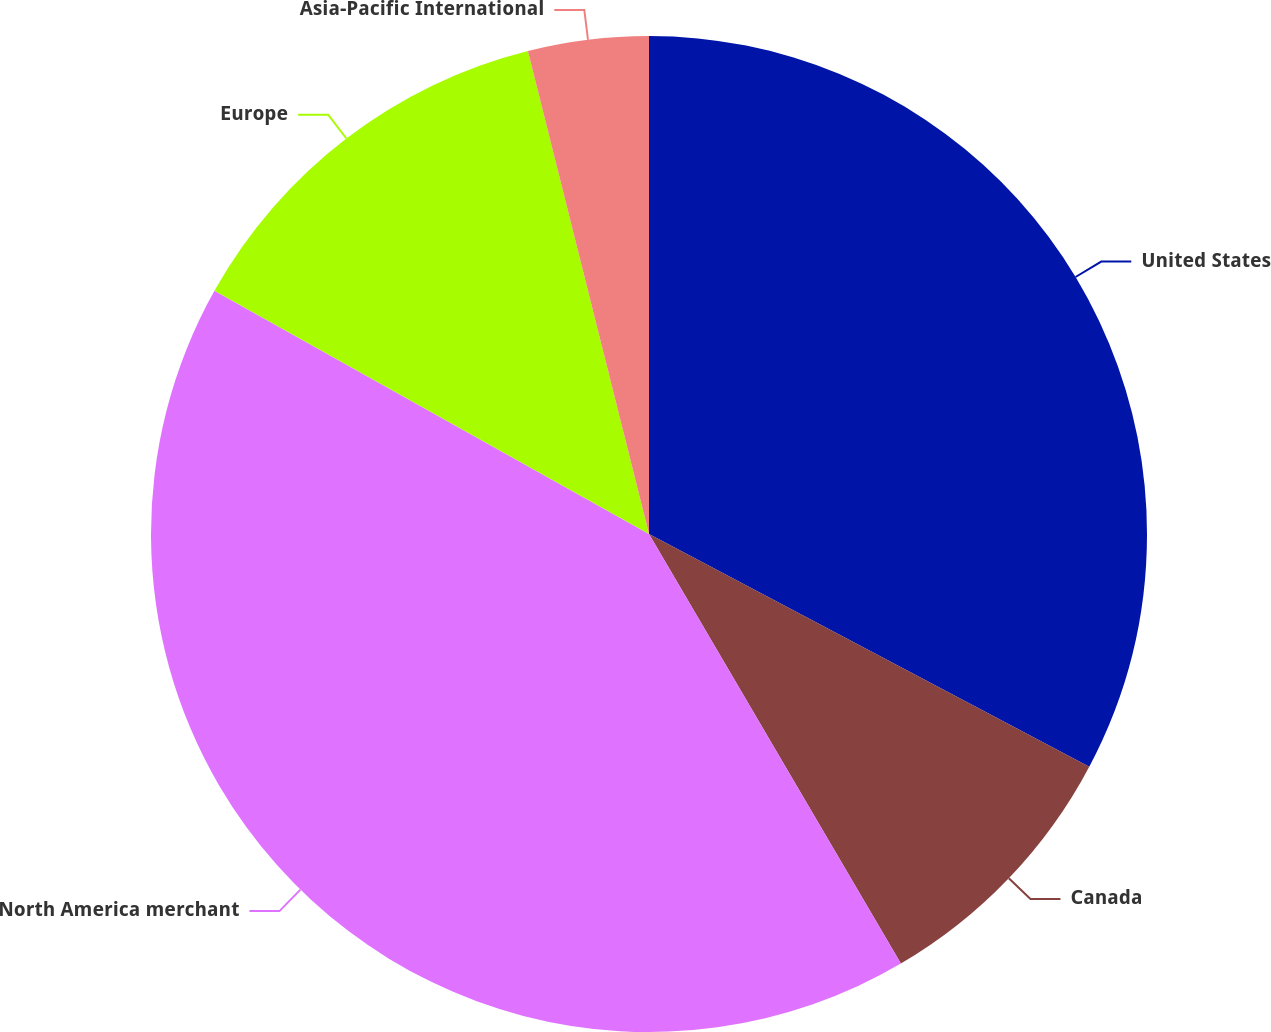Convert chart to OTSL. <chart><loc_0><loc_0><loc_500><loc_500><pie_chart><fcel>United States<fcel>Canada<fcel>North America merchant<fcel>Europe<fcel>Asia-Pacific International<nl><fcel>32.74%<fcel>8.82%<fcel>41.56%<fcel>12.97%<fcel>3.91%<nl></chart> 